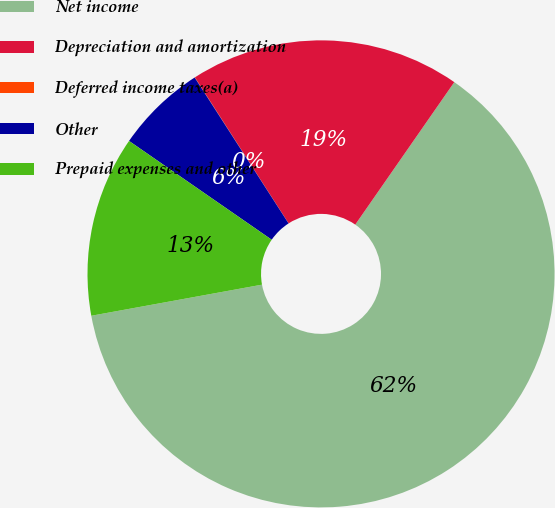Convert chart to OTSL. <chart><loc_0><loc_0><loc_500><loc_500><pie_chart><fcel>Net income<fcel>Depreciation and amortization<fcel>Deferred income taxes(a)<fcel>Other<fcel>Prepaid expenses and other<nl><fcel>62.47%<fcel>18.75%<fcel>0.02%<fcel>6.26%<fcel>12.51%<nl></chart> 